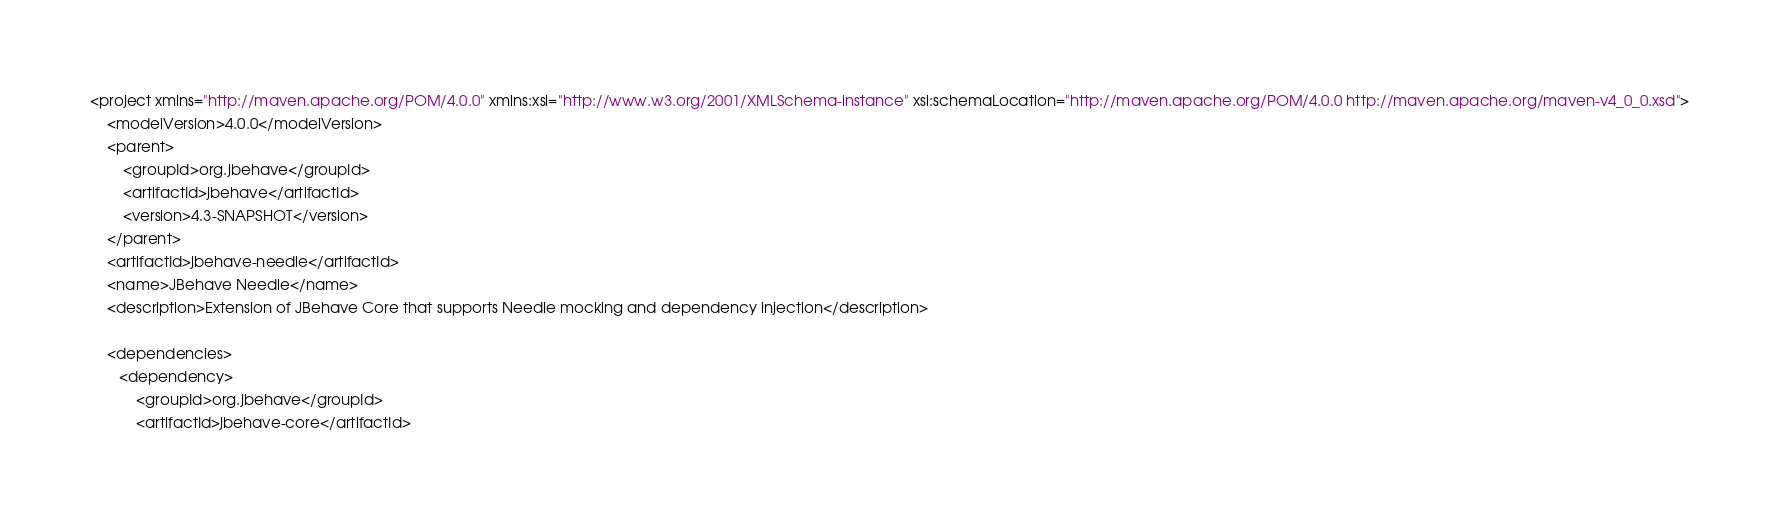Convert code to text. <code><loc_0><loc_0><loc_500><loc_500><_XML_><project xmlns="http://maven.apache.org/POM/4.0.0" xmlns:xsi="http://www.w3.org/2001/XMLSchema-instance" xsi:schemaLocation="http://maven.apache.org/POM/4.0.0 http://maven.apache.org/maven-v4_0_0.xsd">
	<modelVersion>4.0.0</modelVersion>
	<parent>
		<groupId>org.jbehave</groupId>
		<artifactId>jbehave</artifactId>
		<version>4.3-SNAPSHOT</version>
	</parent>
	<artifactId>jbehave-needle</artifactId>
	<name>JBehave Needle</name>
	<description>Extension of JBehave Core that supports Needle mocking and dependency injection</description>

	<dependencies>
       <dependency>
           <groupId>org.jbehave</groupId>
           <artifactId>jbehave-core</artifactId></code> 